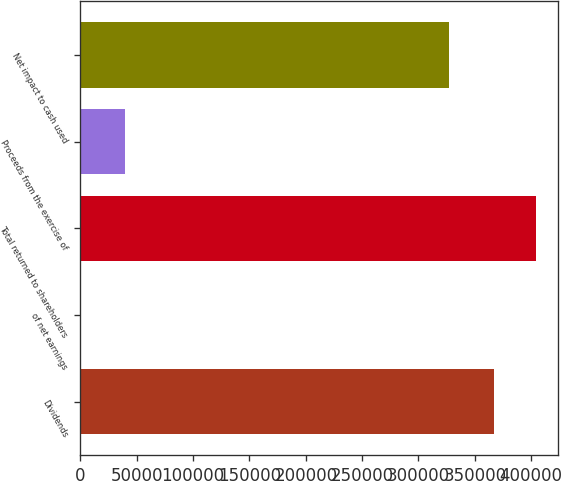Convert chart. <chart><loc_0><loc_0><loc_500><loc_500><bar_chart><fcel>Dividends<fcel>of net earnings<fcel>Total returned to shareholders<fcel>Proceeds from the exercise of<fcel>Net impact to cash used<nl><fcel>367306<fcel>87.3<fcel>404028<fcel>39793<fcel>327513<nl></chart> 